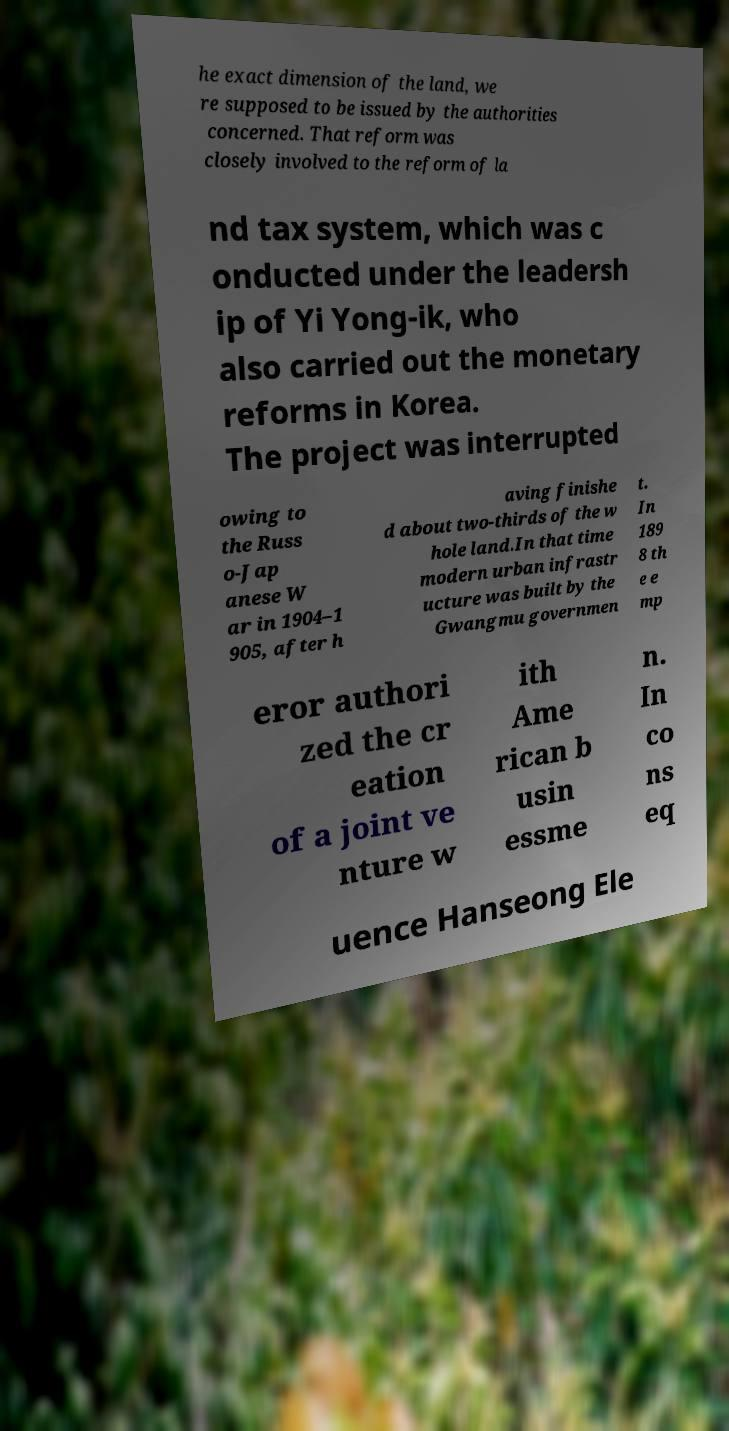Please identify and transcribe the text found in this image. he exact dimension of the land, we re supposed to be issued by the authorities concerned. That reform was closely involved to the reform of la nd tax system, which was c onducted under the leadersh ip of Yi Yong-ik, who also carried out the monetary reforms in Korea. The project was interrupted owing to the Russ o-Jap anese W ar in 1904–1 905, after h aving finishe d about two-thirds of the w hole land.In that time modern urban infrastr ucture was built by the Gwangmu governmen t. In 189 8 th e e mp eror authori zed the cr eation of a joint ve nture w ith Ame rican b usin essme n. In co ns eq uence Hanseong Ele 